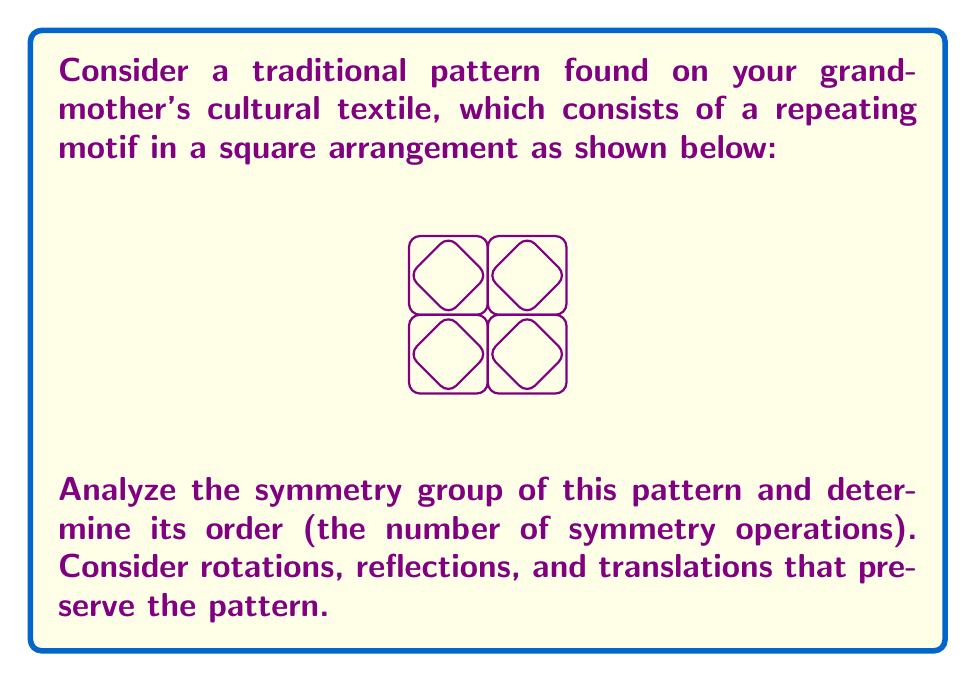Solve this math problem. Let's analyze the symmetry group step-by-step:

1) Rotational symmetry:
   - The pattern has 4-fold rotational symmetry about the center of each square (90°, 180°, 270°, 360°).
   - There's also 2-fold rotational symmetry about the midpoints of the edges of each square.

2) Reflection symmetry:
   - There are horizontal and vertical reflection lines through the centers of the squares.
   - There are also diagonal reflection lines through the corners of the squares.

3) Translational symmetry:
   - The pattern repeats horizontally and vertically with a period of one square width.

To determine the order of the symmetry group, we need to count all distinct symmetry operations:

a) Rotations (about the center of a square):
   - 90°, 180°, 270°, 360° (identity) = 4 operations

b) Reflections:
   - 2 horizontal lines
   - 2 vertical lines
   - 2 diagonal lines
   = 6 operations

c) Translations:
   - Horizontal: 1 square right
   - Vertical: 1 square up
   - Diagonal: 1 square right and 1 square up
   - Identity (no translation)
   = 4 operations

The total number of symmetry operations is the product of these:
$$4 \times 6 \times 4 = 96$$

This symmetry group is known as p4m in the classification of wallpaper groups.
Answer: 96 